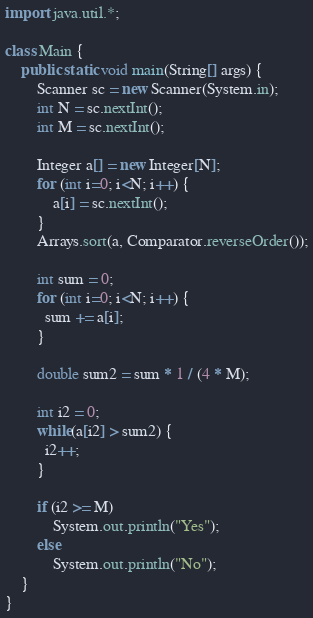Convert code to text. <code><loc_0><loc_0><loc_500><loc_500><_Java_>import java.util.*;

class Main {
    public static void main(String[] args) {
        Scanner sc = new Scanner(System.in);
        int N = sc.nextInt();
        int M = sc.nextInt();
      
      	Integer a[] = new Integer[N];
      	for (int i=0; i<N; i++) {
            a[i] = sc.nextInt();
        }
        Arrays.sort(a, Comparator.reverseOrder());
      
      	int sum = 0;
        for (int i=0; i<N; i++) {
          sum += a[i];
        }
      
      	double sum2 = sum * 1 / (4 * M);

      	int i2 = 0;
      	while(a[i2] > sum2) {
          i2++;
        }
      	
      	if (i2 >= M)
            System.out.println("Yes");
        else
            System.out.println("No");
    }
}</code> 